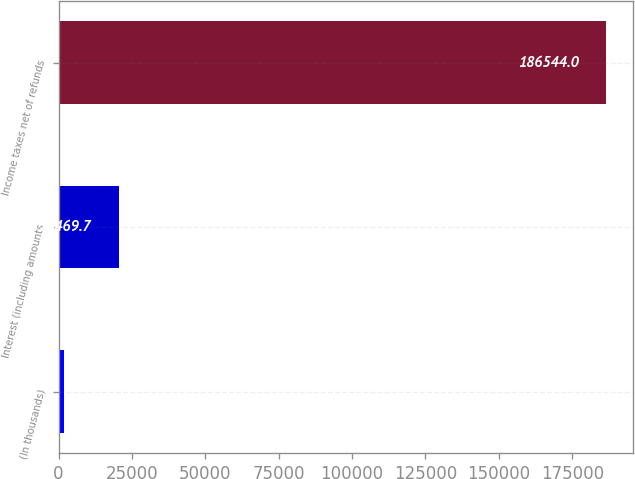<chart> <loc_0><loc_0><loc_500><loc_500><bar_chart><fcel>(In thousands)<fcel>Interest (including amounts<fcel>Income taxes net of refunds<nl><fcel>2017<fcel>20469.7<fcel>186544<nl></chart> 